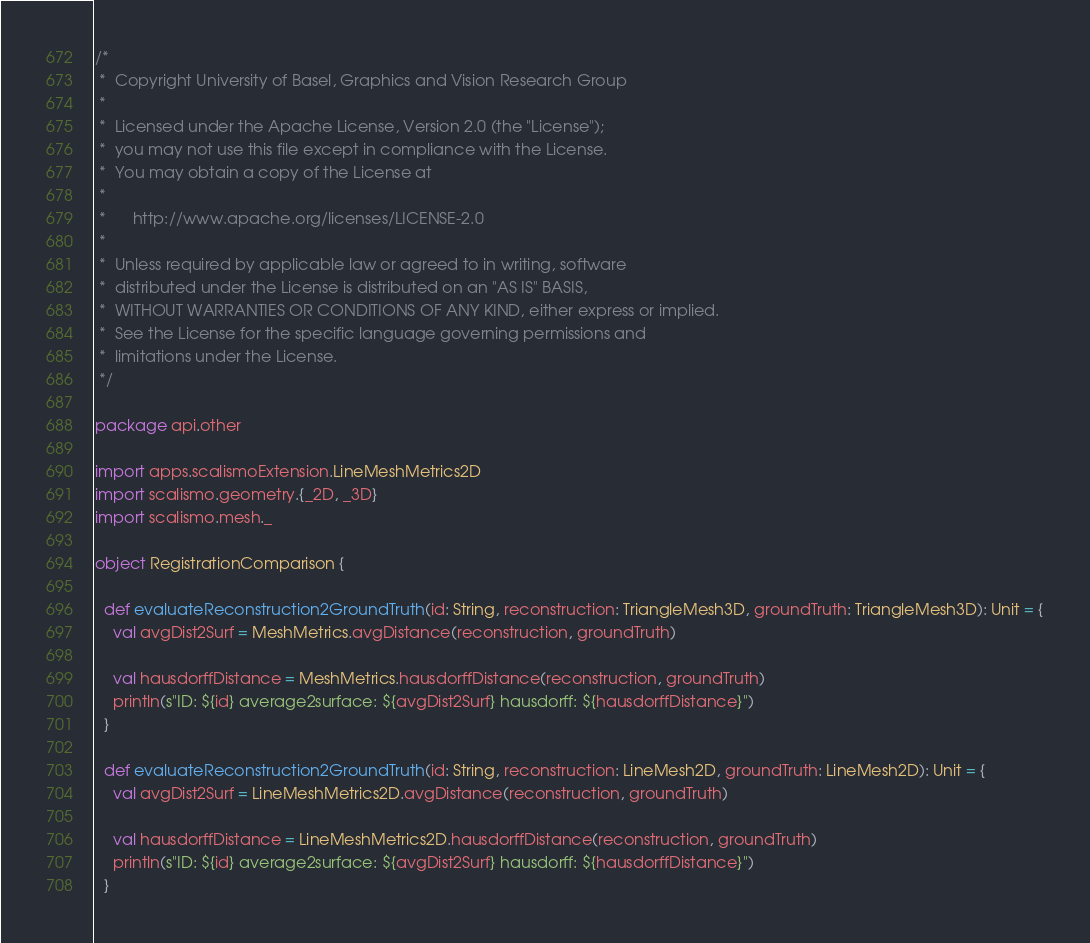Convert code to text. <code><loc_0><loc_0><loc_500><loc_500><_Scala_>/*
 *  Copyright University of Basel, Graphics and Vision Research Group
 *
 *  Licensed under the Apache License, Version 2.0 (the "License");
 *  you may not use this file except in compliance with the License.
 *  You may obtain a copy of the License at
 *
 *      http://www.apache.org/licenses/LICENSE-2.0
 *
 *  Unless required by applicable law or agreed to in writing, software
 *  distributed under the License is distributed on an "AS IS" BASIS,
 *  WITHOUT WARRANTIES OR CONDITIONS OF ANY KIND, either express or implied.
 *  See the License for the specific language governing permissions and
 *  limitations under the License.
 */

package api.other

import apps.scalismoExtension.LineMeshMetrics2D
import scalismo.geometry.{_2D, _3D}
import scalismo.mesh._

object RegistrationComparison {

  def evaluateReconstruction2GroundTruth(id: String, reconstruction: TriangleMesh3D, groundTruth: TriangleMesh3D): Unit = {
    val avgDist2Surf = MeshMetrics.avgDistance(reconstruction, groundTruth)

    val hausdorffDistance = MeshMetrics.hausdorffDistance(reconstruction, groundTruth)
    println(s"ID: ${id} average2surface: ${avgDist2Surf} hausdorff: ${hausdorffDistance}")
  }

  def evaluateReconstruction2GroundTruth(id: String, reconstruction: LineMesh2D, groundTruth: LineMesh2D): Unit = {
    val avgDist2Surf = LineMeshMetrics2D.avgDistance(reconstruction, groundTruth)

    val hausdorffDistance = LineMeshMetrics2D.hausdorffDistance(reconstruction, groundTruth)
    println(s"ID: ${id} average2surface: ${avgDist2Surf} hausdorff: ${hausdorffDistance}")
  }
</code> 